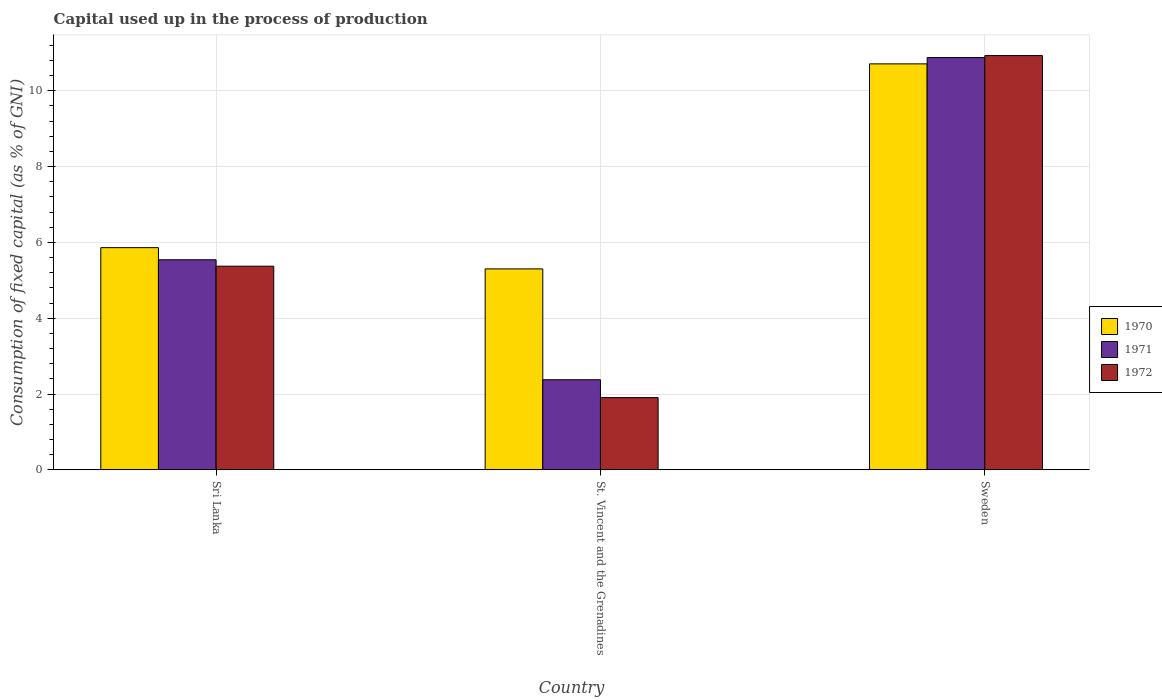How many different coloured bars are there?
Keep it short and to the point. 3. How many groups of bars are there?
Your answer should be very brief. 3. What is the label of the 2nd group of bars from the left?
Provide a succinct answer. St. Vincent and the Grenadines. In how many cases, is the number of bars for a given country not equal to the number of legend labels?
Provide a succinct answer. 0. What is the capital used up in the process of production in 1972 in St. Vincent and the Grenadines?
Keep it short and to the point. 1.9. Across all countries, what is the maximum capital used up in the process of production in 1970?
Make the answer very short. 10.71. Across all countries, what is the minimum capital used up in the process of production in 1971?
Offer a very short reply. 2.38. In which country was the capital used up in the process of production in 1972 maximum?
Your answer should be very brief. Sweden. In which country was the capital used up in the process of production in 1971 minimum?
Make the answer very short. St. Vincent and the Grenadines. What is the total capital used up in the process of production in 1971 in the graph?
Your response must be concise. 18.8. What is the difference between the capital used up in the process of production in 1972 in Sri Lanka and that in St. Vincent and the Grenadines?
Give a very brief answer. 3.47. What is the difference between the capital used up in the process of production in 1972 in Sweden and the capital used up in the process of production in 1971 in St. Vincent and the Grenadines?
Ensure brevity in your answer.  8.55. What is the average capital used up in the process of production in 1972 per country?
Offer a terse response. 6.07. What is the difference between the capital used up in the process of production of/in 1970 and capital used up in the process of production of/in 1972 in Sri Lanka?
Offer a terse response. 0.49. What is the ratio of the capital used up in the process of production in 1971 in St. Vincent and the Grenadines to that in Sweden?
Keep it short and to the point. 0.22. Is the capital used up in the process of production in 1970 in Sri Lanka less than that in St. Vincent and the Grenadines?
Provide a succinct answer. No. What is the difference between the highest and the second highest capital used up in the process of production in 1970?
Give a very brief answer. 4.85. What is the difference between the highest and the lowest capital used up in the process of production in 1970?
Ensure brevity in your answer.  5.41. In how many countries, is the capital used up in the process of production in 1970 greater than the average capital used up in the process of production in 1970 taken over all countries?
Your response must be concise. 1. Are all the bars in the graph horizontal?
Your response must be concise. No. Are the values on the major ticks of Y-axis written in scientific E-notation?
Provide a succinct answer. No. Where does the legend appear in the graph?
Make the answer very short. Center right. How many legend labels are there?
Provide a succinct answer. 3. How are the legend labels stacked?
Provide a short and direct response. Vertical. What is the title of the graph?
Ensure brevity in your answer.  Capital used up in the process of production. Does "1992" appear as one of the legend labels in the graph?
Offer a very short reply. No. What is the label or title of the Y-axis?
Offer a terse response. Consumption of fixed capital (as % of GNI). What is the Consumption of fixed capital (as % of GNI) in 1970 in Sri Lanka?
Your answer should be compact. 5.86. What is the Consumption of fixed capital (as % of GNI) of 1971 in Sri Lanka?
Keep it short and to the point. 5.54. What is the Consumption of fixed capital (as % of GNI) of 1972 in Sri Lanka?
Provide a succinct answer. 5.37. What is the Consumption of fixed capital (as % of GNI) in 1970 in St. Vincent and the Grenadines?
Keep it short and to the point. 5.3. What is the Consumption of fixed capital (as % of GNI) in 1971 in St. Vincent and the Grenadines?
Give a very brief answer. 2.38. What is the Consumption of fixed capital (as % of GNI) of 1972 in St. Vincent and the Grenadines?
Provide a short and direct response. 1.9. What is the Consumption of fixed capital (as % of GNI) in 1970 in Sweden?
Provide a succinct answer. 10.71. What is the Consumption of fixed capital (as % of GNI) of 1971 in Sweden?
Ensure brevity in your answer.  10.88. What is the Consumption of fixed capital (as % of GNI) of 1972 in Sweden?
Your response must be concise. 10.93. Across all countries, what is the maximum Consumption of fixed capital (as % of GNI) of 1970?
Ensure brevity in your answer.  10.71. Across all countries, what is the maximum Consumption of fixed capital (as % of GNI) in 1971?
Your answer should be very brief. 10.88. Across all countries, what is the maximum Consumption of fixed capital (as % of GNI) in 1972?
Make the answer very short. 10.93. Across all countries, what is the minimum Consumption of fixed capital (as % of GNI) of 1970?
Make the answer very short. 5.3. Across all countries, what is the minimum Consumption of fixed capital (as % of GNI) of 1971?
Provide a succinct answer. 2.38. Across all countries, what is the minimum Consumption of fixed capital (as % of GNI) of 1972?
Offer a very short reply. 1.9. What is the total Consumption of fixed capital (as % of GNI) of 1970 in the graph?
Your answer should be very brief. 21.87. What is the total Consumption of fixed capital (as % of GNI) in 1971 in the graph?
Offer a very short reply. 18.8. What is the total Consumption of fixed capital (as % of GNI) of 1972 in the graph?
Your answer should be very brief. 18.21. What is the difference between the Consumption of fixed capital (as % of GNI) of 1970 in Sri Lanka and that in St. Vincent and the Grenadines?
Make the answer very short. 0.56. What is the difference between the Consumption of fixed capital (as % of GNI) in 1971 in Sri Lanka and that in St. Vincent and the Grenadines?
Give a very brief answer. 3.16. What is the difference between the Consumption of fixed capital (as % of GNI) in 1972 in Sri Lanka and that in St. Vincent and the Grenadines?
Your answer should be compact. 3.47. What is the difference between the Consumption of fixed capital (as % of GNI) in 1970 in Sri Lanka and that in Sweden?
Provide a succinct answer. -4.85. What is the difference between the Consumption of fixed capital (as % of GNI) of 1971 in Sri Lanka and that in Sweden?
Your answer should be very brief. -5.34. What is the difference between the Consumption of fixed capital (as % of GNI) in 1972 in Sri Lanka and that in Sweden?
Make the answer very short. -5.56. What is the difference between the Consumption of fixed capital (as % of GNI) in 1970 in St. Vincent and the Grenadines and that in Sweden?
Give a very brief answer. -5.41. What is the difference between the Consumption of fixed capital (as % of GNI) in 1971 in St. Vincent and the Grenadines and that in Sweden?
Make the answer very short. -8.5. What is the difference between the Consumption of fixed capital (as % of GNI) of 1972 in St. Vincent and the Grenadines and that in Sweden?
Provide a succinct answer. -9.02. What is the difference between the Consumption of fixed capital (as % of GNI) in 1970 in Sri Lanka and the Consumption of fixed capital (as % of GNI) in 1971 in St. Vincent and the Grenadines?
Your answer should be very brief. 3.48. What is the difference between the Consumption of fixed capital (as % of GNI) in 1970 in Sri Lanka and the Consumption of fixed capital (as % of GNI) in 1972 in St. Vincent and the Grenadines?
Keep it short and to the point. 3.96. What is the difference between the Consumption of fixed capital (as % of GNI) in 1971 in Sri Lanka and the Consumption of fixed capital (as % of GNI) in 1972 in St. Vincent and the Grenadines?
Ensure brevity in your answer.  3.64. What is the difference between the Consumption of fixed capital (as % of GNI) of 1970 in Sri Lanka and the Consumption of fixed capital (as % of GNI) of 1971 in Sweden?
Your answer should be very brief. -5.02. What is the difference between the Consumption of fixed capital (as % of GNI) in 1970 in Sri Lanka and the Consumption of fixed capital (as % of GNI) in 1972 in Sweden?
Your answer should be compact. -5.07. What is the difference between the Consumption of fixed capital (as % of GNI) of 1971 in Sri Lanka and the Consumption of fixed capital (as % of GNI) of 1972 in Sweden?
Offer a very short reply. -5.39. What is the difference between the Consumption of fixed capital (as % of GNI) of 1970 in St. Vincent and the Grenadines and the Consumption of fixed capital (as % of GNI) of 1971 in Sweden?
Your answer should be very brief. -5.58. What is the difference between the Consumption of fixed capital (as % of GNI) in 1970 in St. Vincent and the Grenadines and the Consumption of fixed capital (as % of GNI) in 1972 in Sweden?
Your answer should be very brief. -5.63. What is the difference between the Consumption of fixed capital (as % of GNI) of 1971 in St. Vincent and the Grenadines and the Consumption of fixed capital (as % of GNI) of 1972 in Sweden?
Provide a succinct answer. -8.55. What is the average Consumption of fixed capital (as % of GNI) in 1970 per country?
Your answer should be compact. 7.29. What is the average Consumption of fixed capital (as % of GNI) of 1971 per country?
Your response must be concise. 6.27. What is the average Consumption of fixed capital (as % of GNI) in 1972 per country?
Ensure brevity in your answer.  6.07. What is the difference between the Consumption of fixed capital (as % of GNI) in 1970 and Consumption of fixed capital (as % of GNI) in 1971 in Sri Lanka?
Offer a terse response. 0.32. What is the difference between the Consumption of fixed capital (as % of GNI) in 1970 and Consumption of fixed capital (as % of GNI) in 1972 in Sri Lanka?
Provide a short and direct response. 0.49. What is the difference between the Consumption of fixed capital (as % of GNI) of 1971 and Consumption of fixed capital (as % of GNI) of 1972 in Sri Lanka?
Ensure brevity in your answer.  0.17. What is the difference between the Consumption of fixed capital (as % of GNI) in 1970 and Consumption of fixed capital (as % of GNI) in 1971 in St. Vincent and the Grenadines?
Your answer should be compact. 2.92. What is the difference between the Consumption of fixed capital (as % of GNI) in 1970 and Consumption of fixed capital (as % of GNI) in 1972 in St. Vincent and the Grenadines?
Your response must be concise. 3.4. What is the difference between the Consumption of fixed capital (as % of GNI) in 1971 and Consumption of fixed capital (as % of GNI) in 1972 in St. Vincent and the Grenadines?
Ensure brevity in your answer.  0.47. What is the difference between the Consumption of fixed capital (as % of GNI) in 1970 and Consumption of fixed capital (as % of GNI) in 1971 in Sweden?
Keep it short and to the point. -0.17. What is the difference between the Consumption of fixed capital (as % of GNI) of 1970 and Consumption of fixed capital (as % of GNI) of 1972 in Sweden?
Give a very brief answer. -0.22. What is the difference between the Consumption of fixed capital (as % of GNI) in 1971 and Consumption of fixed capital (as % of GNI) in 1972 in Sweden?
Provide a short and direct response. -0.05. What is the ratio of the Consumption of fixed capital (as % of GNI) of 1970 in Sri Lanka to that in St. Vincent and the Grenadines?
Your answer should be very brief. 1.11. What is the ratio of the Consumption of fixed capital (as % of GNI) in 1971 in Sri Lanka to that in St. Vincent and the Grenadines?
Your answer should be very brief. 2.33. What is the ratio of the Consumption of fixed capital (as % of GNI) of 1972 in Sri Lanka to that in St. Vincent and the Grenadines?
Your answer should be very brief. 2.82. What is the ratio of the Consumption of fixed capital (as % of GNI) of 1970 in Sri Lanka to that in Sweden?
Your response must be concise. 0.55. What is the ratio of the Consumption of fixed capital (as % of GNI) in 1971 in Sri Lanka to that in Sweden?
Give a very brief answer. 0.51. What is the ratio of the Consumption of fixed capital (as % of GNI) of 1972 in Sri Lanka to that in Sweden?
Give a very brief answer. 0.49. What is the ratio of the Consumption of fixed capital (as % of GNI) in 1970 in St. Vincent and the Grenadines to that in Sweden?
Offer a terse response. 0.49. What is the ratio of the Consumption of fixed capital (as % of GNI) in 1971 in St. Vincent and the Grenadines to that in Sweden?
Your answer should be very brief. 0.22. What is the ratio of the Consumption of fixed capital (as % of GNI) of 1972 in St. Vincent and the Grenadines to that in Sweden?
Provide a short and direct response. 0.17. What is the difference between the highest and the second highest Consumption of fixed capital (as % of GNI) in 1970?
Ensure brevity in your answer.  4.85. What is the difference between the highest and the second highest Consumption of fixed capital (as % of GNI) of 1971?
Offer a very short reply. 5.34. What is the difference between the highest and the second highest Consumption of fixed capital (as % of GNI) of 1972?
Keep it short and to the point. 5.56. What is the difference between the highest and the lowest Consumption of fixed capital (as % of GNI) of 1970?
Offer a very short reply. 5.41. What is the difference between the highest and the lowest Consumption of fixed capital (as % of GNI) of 1971?
Offer a very short reply. 8.5. What is the difference between the highest and the lowest Consumption of fixed capital (as % of GNI) in 1972?
Provide a succinct answer. 9.02. 